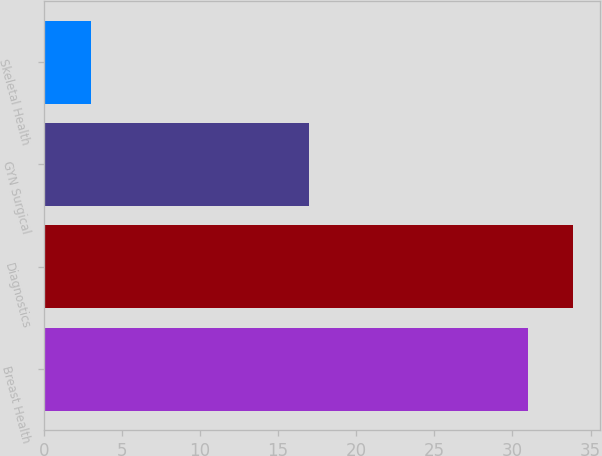Convert chart. <chart><loc_0><loc_0><loc_500><loc_500><bar_chart><fcel>Breast Health<fcel>Diagnostics<fcel>GYN Surgical<fcel>Skeletal Health<nl><fcel>31<fcel>33.9<fcel>17<fcel>3<nl></chart> 